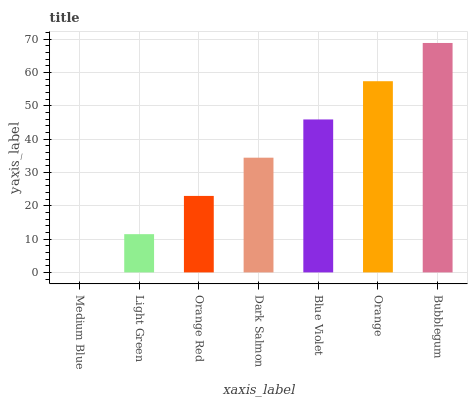Is Light Green the minimum?
Answer yes or no. No. Is Light Green the maximum?
Answer yes or no. No. Is Light Green greater than Medium Blue?
Answer yes or no. Yes. Is Medium Blue less than Light Green?
Answer yes or no. Yes. Is Medium Blue greater than Light Green?
Answer yes or no. No. Is Light Green less than Medium Blue?
Answer yes or no. No. Is Dark Salmon the high median?
Answer yes or no. Yes. Is Dark Salmon the low median?
Answer yes or no. Yes. Is Light Green the high median?
Answer yes or no. No. Is Orange Red the low median?
Answer yes or no. No. 